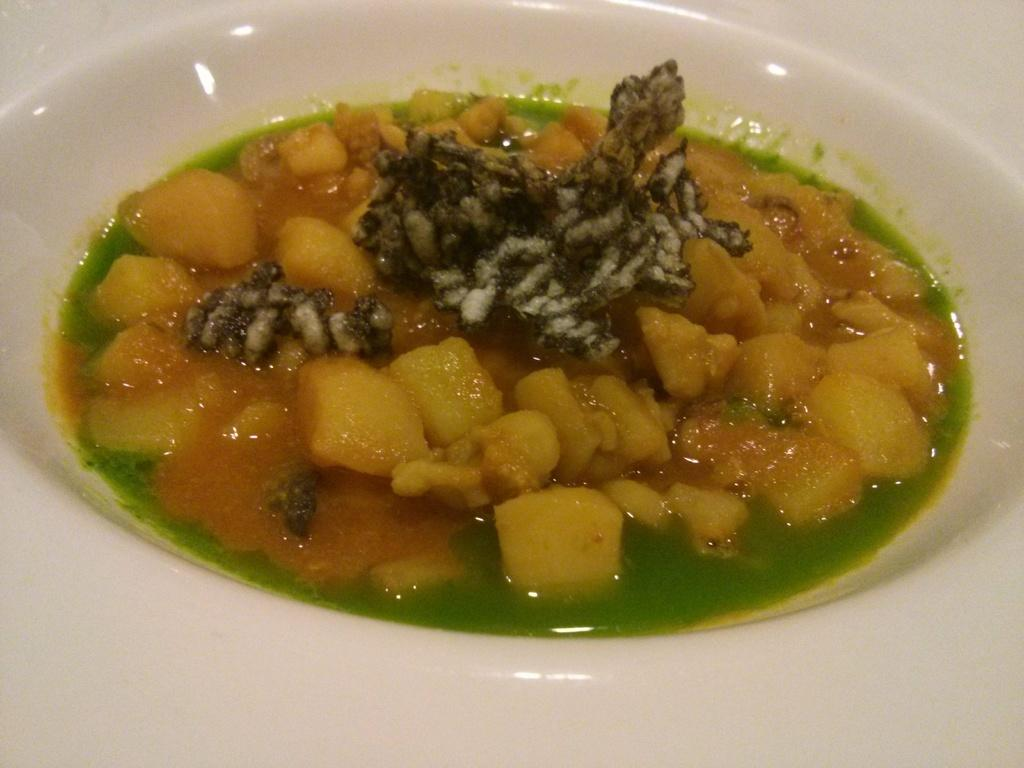What object can be seen in the image that is typically used for serving food? There is a plate in the image. What is on the plate that is being served? There is food on the plate. Can you see a ghost interacting with the plate in the image? No, there is no ghost present in the image. 